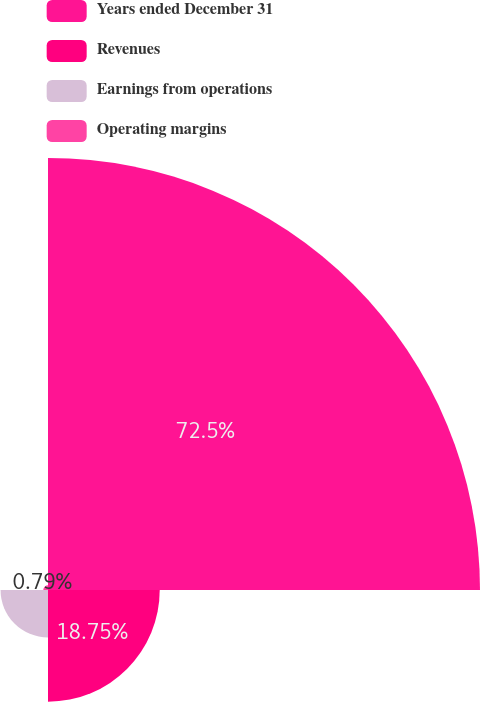<chart> <loc_0><loc_0><loc_500><loc_500><pie_chart><fcel>Years ended December 31<fcel>Revenues<fcel>Earnings from operations<fcel>Operating margins<nl><fcel>72.5%<fcel>18.75%<fcel>7.96%<fcel>0.79%<nl></chart> 